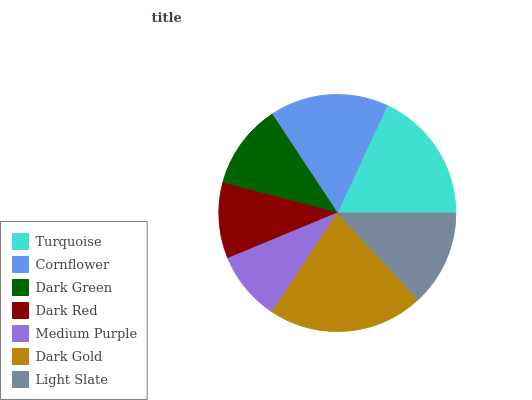Is Medium Purple the minimum?
Answer yes or no. Yes. Is Dark Gold the maximum?
Answer yes or no. Yes. Is Cornflower the minimum?
Answer yes or no. No. Is Cornflower the maximum?
Answer yes or no. No. Is Turquoise greater than Cornflower?
Answer yes or no. Yes. Is Cornflower less than Turquoise?
Answer yes or no. Yes. Is Cornflower greater than Turquoise?
Answer yes or no. No. Is Turquoise less than Cornflower?
Answer yes or no. No. Is Light Slate the high median?
Answer yes or no. Yes. Is Light Slate the low median?
Answer yes or no. Yes. Is Turquoise the high median?
Answer yes or no. No. Is Dark Red the low median?
Answer yes or no. No. 